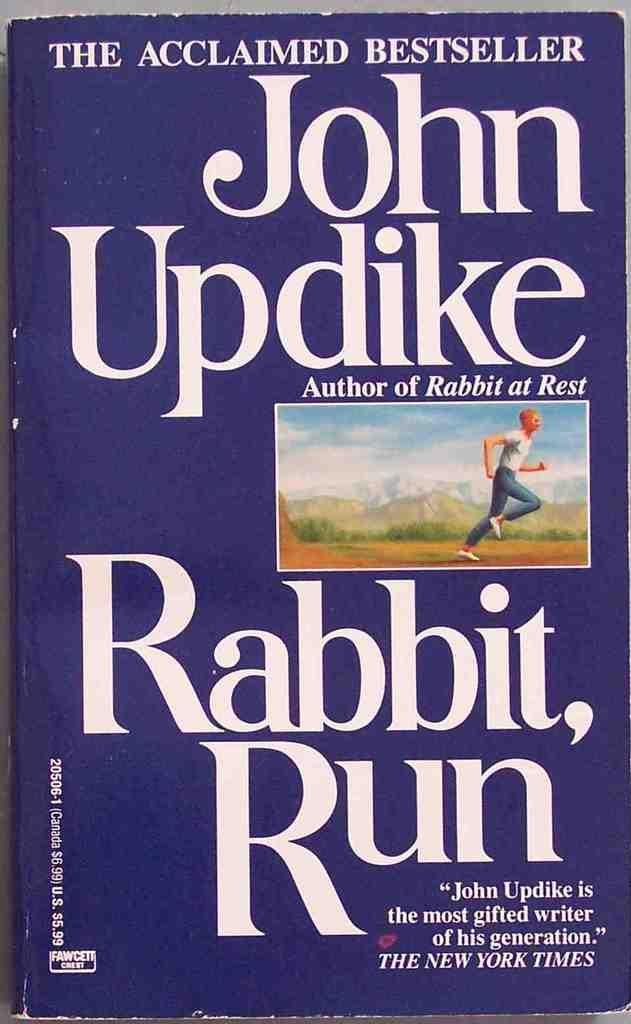<image>
Summarize the visual content of the image. A book by John Updike titled "Rabbit Run". 